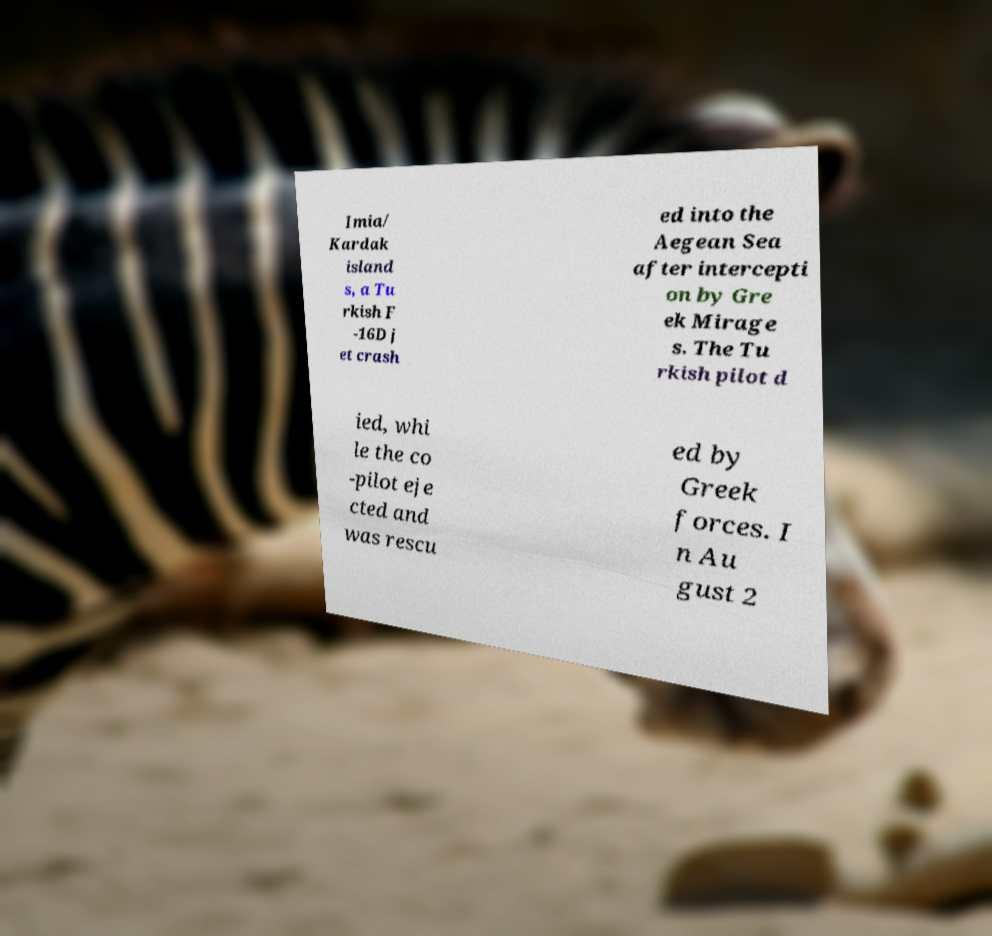Can you accurately transcribe the text from the provided image for me? Imia/ Kardak island s, a Tu rkish F -16D j et crash ed into the Aegean Sea after intercepti on by Gre ek Mirage s. The Tu rkish pilot d ied, whi le the co -pilot eje cted and was rescu ed by Greek forces. I n Au gust 2 